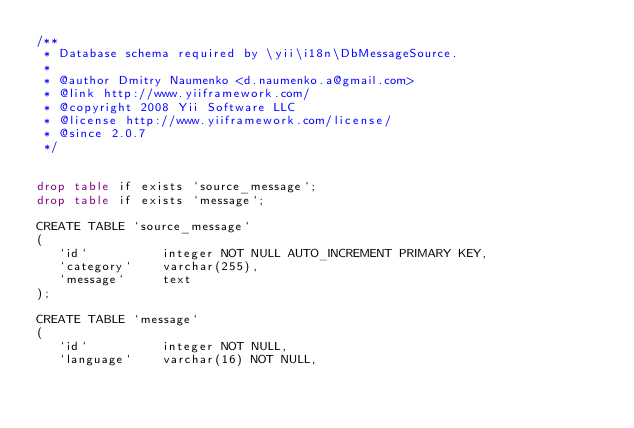<code> <loc_0><loc_0><loc_500><loc_500><_SQL_>/**
 * Database schema required by \yii\i18n\DbMessageSource.
 *
 * @author Dmitry Naumenko <d.naumenko.a@gmail.com>
 * @link http://www.yiiframework.com/
 * @copyright 2008 Yii Software LLC
 * @license http://www.yiiframework.com/license/
 * @since 2.0.7
 */


drop table if exists `source_message`;
drop table if exists `message`;

CREATE TABLE `source_message`
(
   `id`          integer NOT NULL AUTO_INCREMENT PRIMARY KEY,
   `category`    varchar(255),
   `message`     text
);

CREATE TABLE `message`
(
   `id`          integer NOT NULL,
   `language`    varchar(16) NOT NULL,</code> 